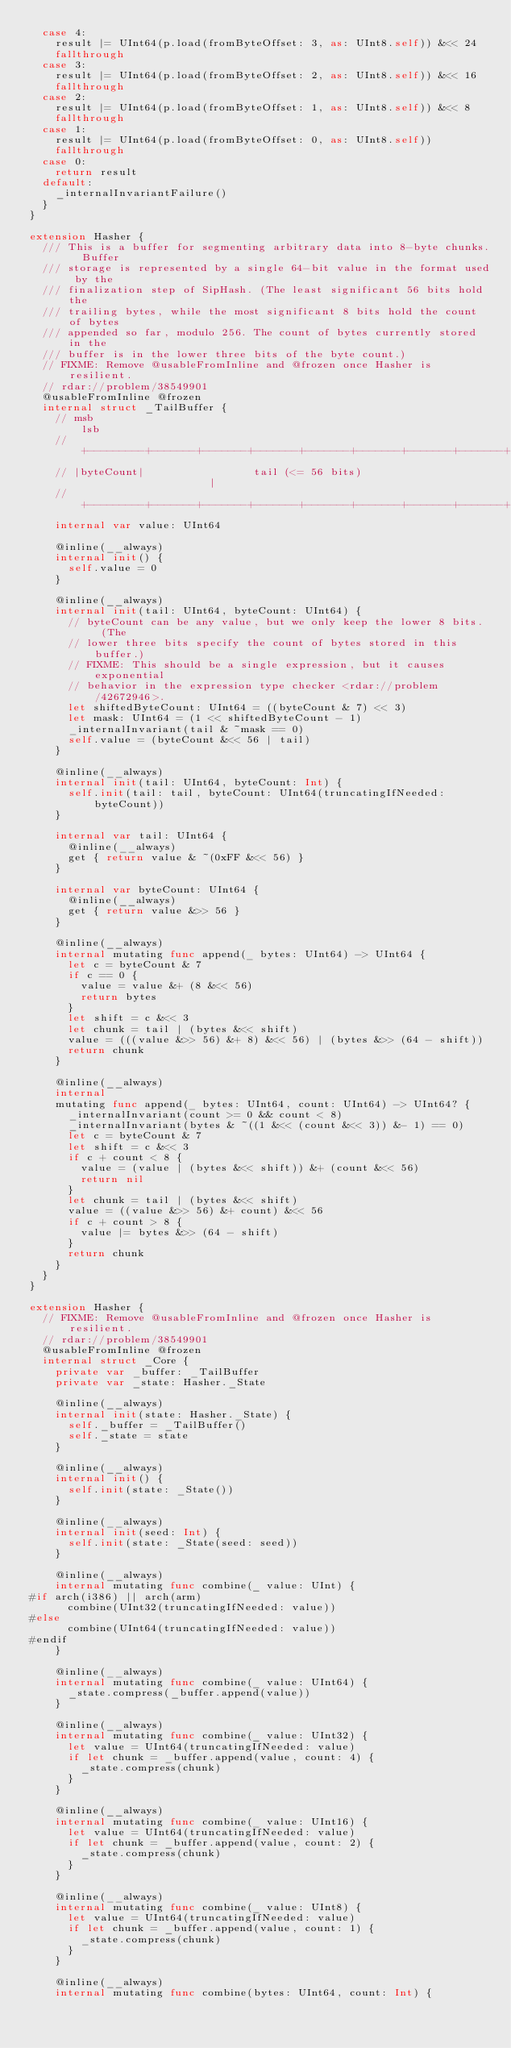Convert code to text. <code><loc_0><loc_0><loc_500><loc_500><_Swift_>  case 4:
    result |= UInt64(p.load(fromByteOffset: 3, as: UInt8.self)) &<< 24
    fallthrough
  case 3:
    result |= UInt64(p.load(fromByteOffset: 2, as: UInt8.self)) &<< 16
    fallthrough
  case 2:
    result |= UInt64(p.load(fromByteOffset: 1, as: UInt8.self)) &<< 8
    fallthrough
  case 1:
    result |= UInt64(p.load(fromByteOffset: 0, as: UInt8.self))
    fallthrough
  case 0:
    return result
  default:
    _internalInvariantFailure()
  }
}

extension Hasher {
  /// This is a buffer for segmenting arbitrary data into 8-byte chunks.  Buffer
  /// storage is represented by a single 64-bit value in the format used by the
  /// finalization step of SipHash. (The least significant 56 bits hold the
  /// trailing bytes, while the most significant 8 bits hold the count of bytes
  /// appended so far, modulo 256. The count of bytes currently stored in the
  /// buffer is in the lower three bits of the byte count.)
  // FIXME: Remove @usableFromInline and @frozen once Hasher is resilient.
  // rdar://problem/38549901
  @usableFromInline @frozen
  internal struct _TailBuffer {
    // msb                                                             lsb
    // +---------+-------+-------+-------+-------+-------+-------+-------+
    // |byteCount|                 tail (<= 56 bits)                     |
    // +---------+-------+-------+-------+-------+-------+-------+-------+
    internal var value: UInt64

    @inline(__always)
    internal init() {
      self.value = 0
    }

    @inline(__always)
    internal init(tail: UInt64, byteCount: UInt64) {
      // byteCount can be any value, but we only keep the lower 8 bits.  (The
      // lower three bits specify the count of bytes stored in this buffer.)
      // FIXME: This should be a single expression, but it causes exponential
      // behavior in the expression type checker <rdar://problem/42672946>.
      let shiftedByteCount: UInt64 = ((byteCount & 7) << 3)
      let mask: UInt64 = (1 << shiftedByteCount - 1)
      _internalInvariant(tail & ~mask == 0)
      self.value = (byteCount &<< 56 | tail)
    }

    @inline(__always)
    internal init(tail: UInt64, byteCount: Int) {
      self.init(tail: tail, byteCount: UInt64(truncatingIfNeeded: byteCount))
    }

    internal var tail: UInt64 {
      @inline(__always)
      get { return value & ~(0xFF &<< 56) }
    }

    internal var byteCount: UInt64 {
      @inline(__always)
      get { return value &>> 56 }
    }

    @inline(__always)
    internal mutating func append(_ bytes: UInt64) -> UInt64 {
      let c = byteCount & 7
      if c == 0 {
        value = value &+ (8 &<< 56)
        return bytes
      }
      let shift = c &<< 3
      let chunk = tail | (bytes &<< shift)
      value = (((value &>> 56) &+ 8) &<< 56) | (bytes &>> (64 - shift))
      return chunk
    }

    @inline(__always)
    internal
    mutating func append(_ bytes: UInt64, count: UInt64) -> UInt64? {
      _internalInvariant(count >= 0 && count < 8)
      _internalInvariant(bytes & ~((1 &<< (count &<< 3)) &- 1) == 0)
      let c = byteCount & 7
      let shift = c &<< 3
      if c + count < 8 {
        value = (value | (bytes &<< shift)) &+ (count &<< 56)
        return nil
      }
      let chunk = tail | (bytes &<< shift)
      value = ((value &>> 56) &+ count) &<< 56
      if c + count > 8 {
        value |= bytes &>> (64 - shift)
      }
      return chunk
    }
  }
}

extension Hasher {
  // FIXME: Remove @usableFromInline and @frozen once Hasher is resilient.
  // rdar://problem/38549901
  @usableFromInline @frozen
  internal struct _Core {
    private var _buffer: _TailBuffer
    private var _state: Hasher._State

    @inline(__always)
    internal init(state: Hasher._State) {
      self._buffer = _TailBuffer()
      self._state = state
    }

    @inline(__always)
    internal init() {
      self.init(state: _State())
    }

    @inline(__always)
    internal init(seed: Int) {
      self.init(state: _State(seed: seed))
    }

    @inline(__always)
    internal mutating func combine(_ value: UInt) {
#if arch(i386) || arch(arm)
      combine(UInt32(truncatingIfNeeded: value))
#else
      combine(UInt64(truncatingIfNeeded: value))
#endif
    }

    @inline(__always)
    internal mutating func combine(_ value: UInt64) {
      _state.compress(_buffer.append(value))
    }

    @inline(__always)
    internal mutating func combine(_ value: UInt32) {
      let value = UInt64(truncatingIfNeeded: value)
      if let chunk = _buffer.append(value, count: 4) {
        _state.compress(chunk)
      }
    }

    @inline(__always)
    internal mutating func combine(_ value: UInt16) {
      let value = UInt64(truncatingIfNeeded: value)
      if let chunk = _buffer.append(value, count: 2) {
        _state.compress(chunk)
      }
    }

    @inline(__always)
    internal mutating func combine(_ value: UInt8) {
      let value = UInt64(truncatingIfNeeded: value)
      if let chunk = _buffer.append(value, count: 1) {
        _state.compress(chunk)
      }
    }

    @inline(__always)
    internal mutating func combine(bytes: UInt64, count: Int) {</code> 